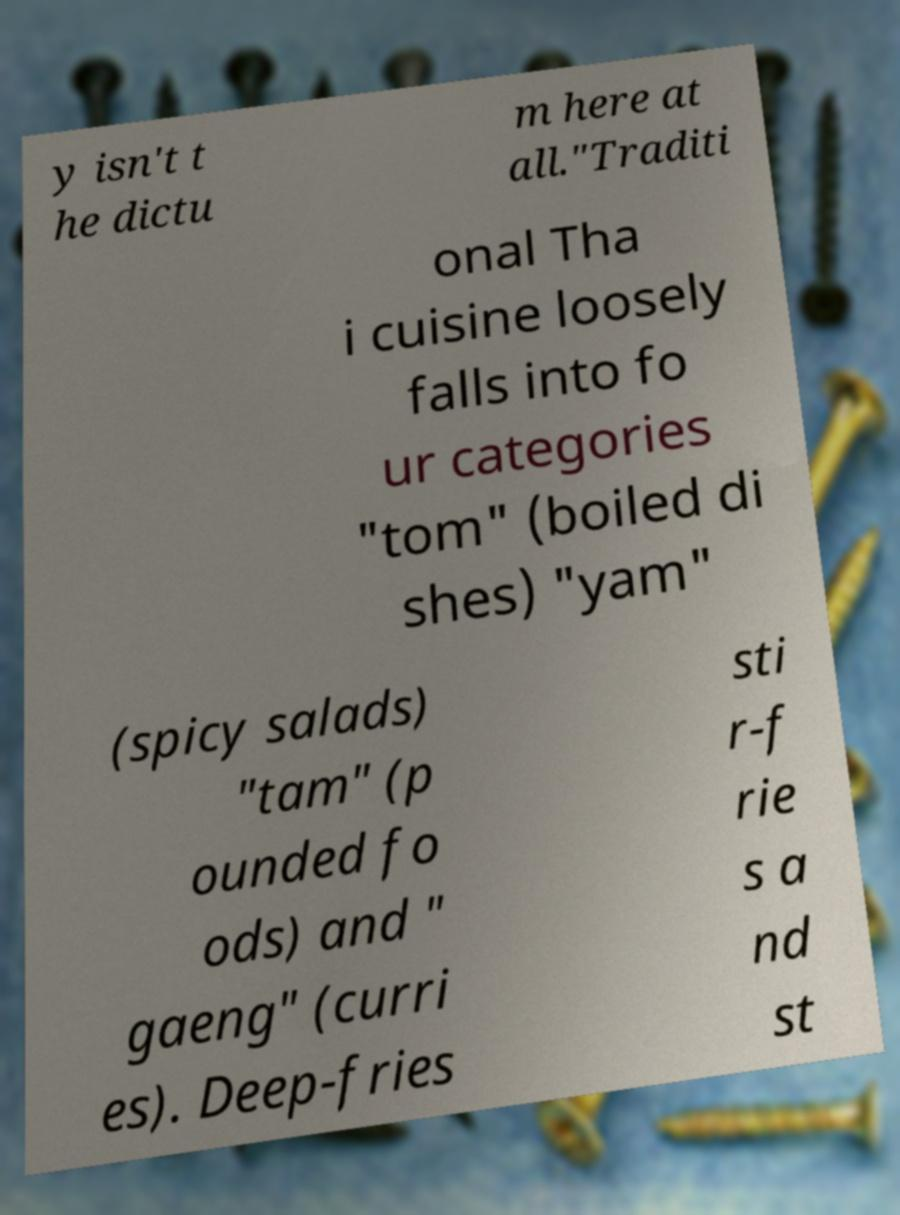Please identify and transcribe the text found in this image. y isn't t he dictu m here at all."Traditi onal Tha i cuisine loosely falls into fo ur categories "tom" (boiled di shes) "yam" (spicy salads) "tam" (p ounded fo ods) and " gaeng" (curri es). Deep-fries sti r-f rie s a nd st 